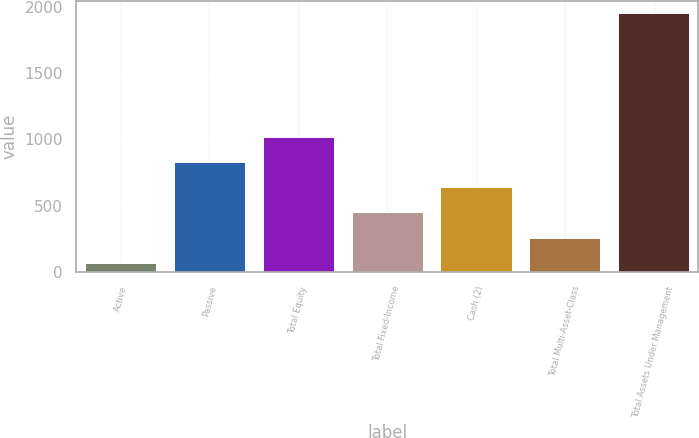<chart> <loc_0><loc_0><loc_500><loc_500><bar_chart><fcel>Active<fcel>Passive<fcel>Total Equity<fcel>Total Fixed-Income<fcel>Cash (2)<fcel>Total Multi-Asset-Class<fcel>Total Assets Under Management<nl><fcel>68<fcel>830.6<fcel>1018.9<fcel>454<fcel>642.3<fcel>256.3<fcel>1951<nl></chart> 